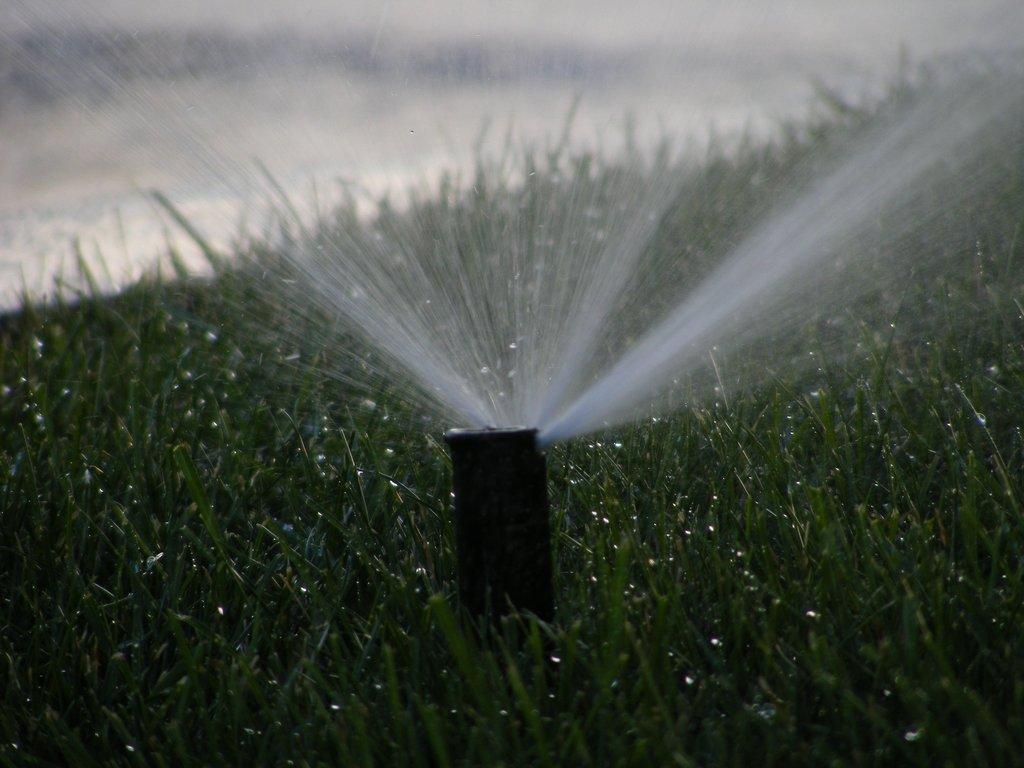Can you describe this image briefly? In this image there is a pole in the middle of grass from which water is coming out. 